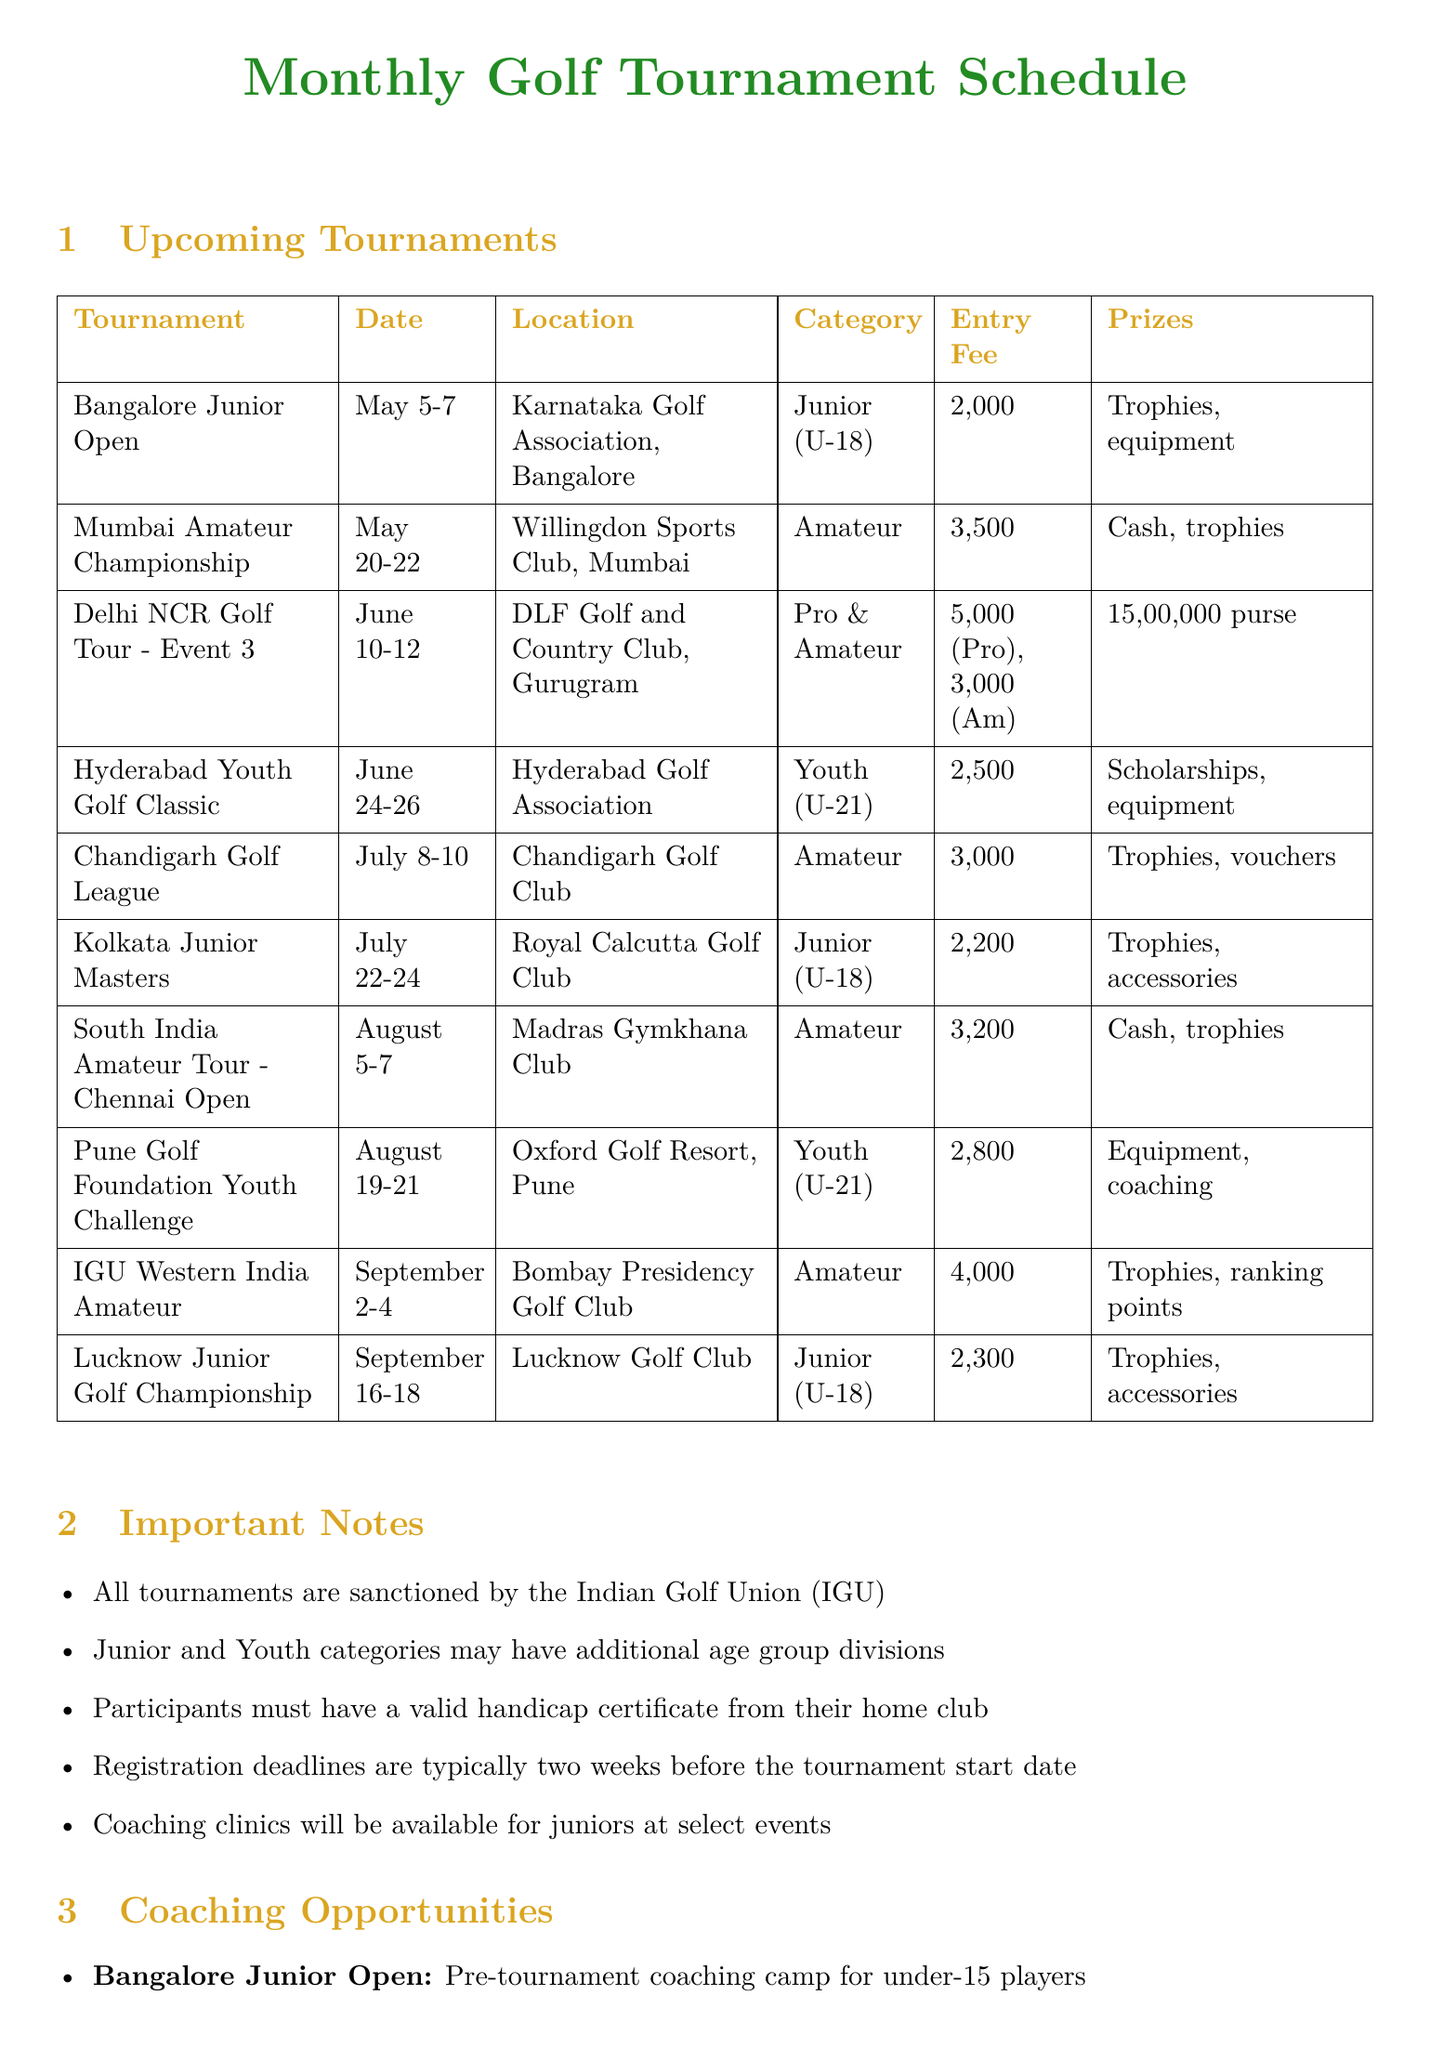what is the date of the Bangalore Junior Open? The date is mentioned in the tournament schedule for the Bangalore Junior Open.
Answer: May 5-7 which tournament has the highest entry fee? The entry fees for each tournament are listed, and the highest is for the Delhi NCR Golf Tour.
Answer: ₹5,000 (Pro) what category is the Hyderabad Youth Golf Classic? The category for the Hyderabad Youth Golf Classic is defined in the document.
Answer: Youth (Under-21) how much is the entry fee for the Kolkata Junior Masters? The entry fee is specified for each tournament, including the Kolkata Junior Masters.
Answer: ₹2,200 which tournament offers scholarships as prizes? The prize details for each tournament include scholarships, particularly in the Hyderabad Youth Golf Classic.
Answer: Hyderabad Youth Golf Classic what type of workshop is available at the Pune Golf Foundation Youth Challenge? The type of workshop is described in the coaching opportunities section of the document.
Answer: Mental game workshop how many tournaments are specifically for juniors under 18? The number of tournaments for juniors can be counted from the document's tournament list.
Answer: 4 is there a coaching clinic available for juniors at the Bangalore Junior Open? The important notes section mentions coaching clinics at select events, including the Bangalore Junior Open.
Answer: Yes 